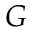Convert formula to latex. <formula><loc_0><loc_0><loc_500><loc_500>G</formula> 